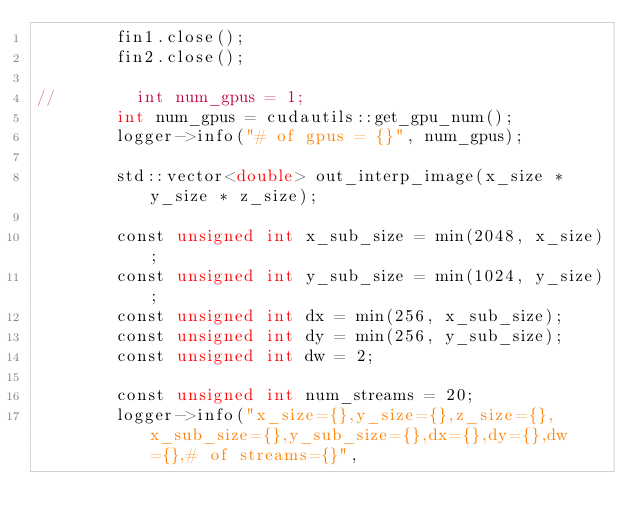<code> <loc_0><loc_0><loc_500><loc_500><_Cuda_>        fin1.close();
        fin2.close();

//        int num_gpus = 1;
        int num_gpus = cudautils::get_gpu_num();
        logger->info("# of gpus = {}", num_gpus);

        std::vector<double> out_interp_image(x_size * y_size * z_size);

        const unsigned int x_sub_size = min(2048, x_size);
        const unsigned int y_sub_size = min(1024, y_size);
        const unsigned int dx = min(256, x_sub_size);
        const unsigned int dy = min(256, y_sub_size);
        const unsigned int dw = 2;

        const unsigned int num_streams = 20;
        logger->info("x_size={},y_size={},z_size={},x_sub_size={},y_sub_size={},dx={},dy={},dw={},# of streams={}",</code> 